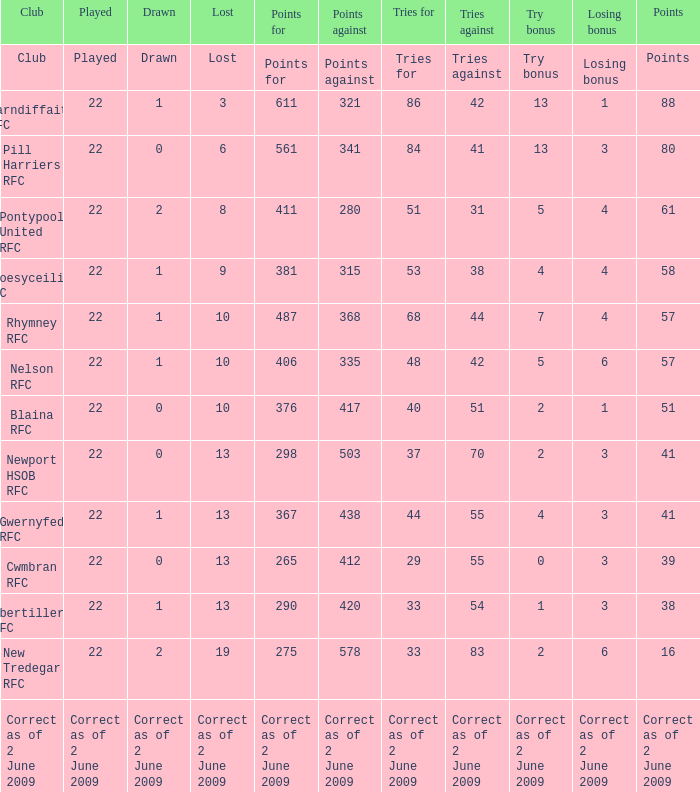What was the number of attempts against for the club with 1 draw and 41 points? 55.0. 